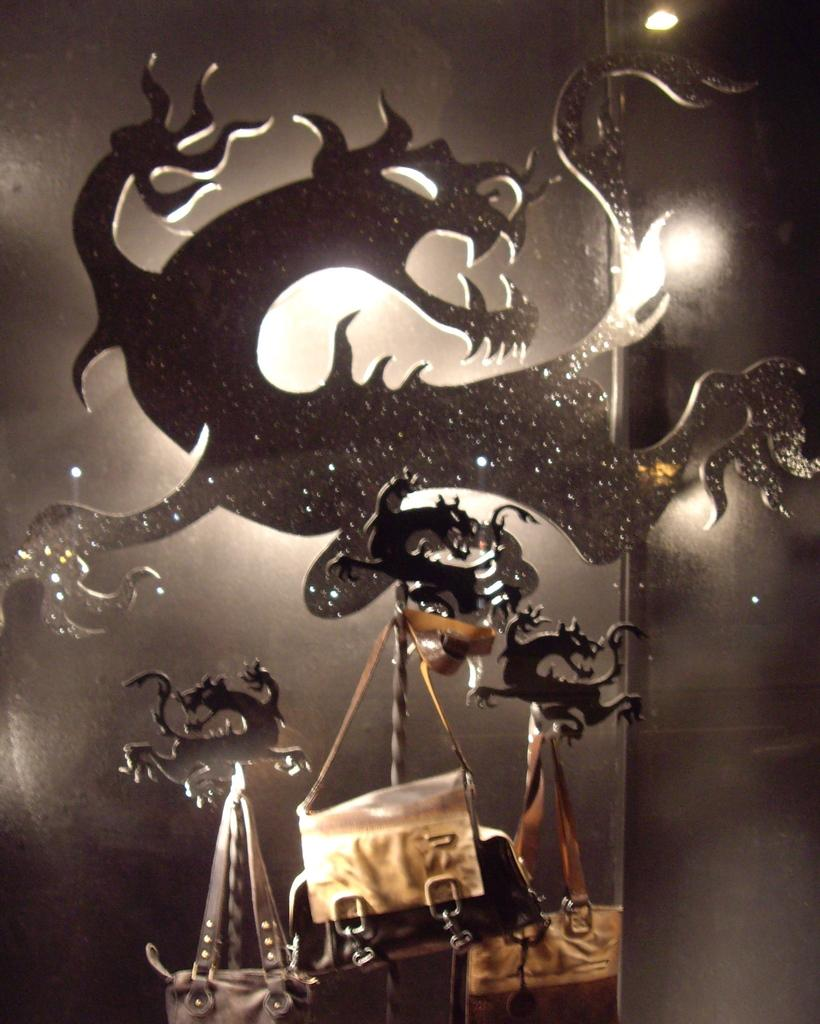What is the main object in the image? There is a stand in the image. What is unique about the design of the stand? The stand is in the shape of a dragon. What items are hanging on the stand? There are handbags hanging on the stand. What type of pancake is being served on the dragon stand in the image? There is no pancake present in the image; it features a dragon-shaped stand with handbags hanging on it. 